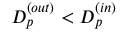<formula> <loc_0><loc_0><loc_500><loc_500>D _ { p } ^ { ( o u t ) } < D _ { p } ^ { ( i n ) }</formula> 